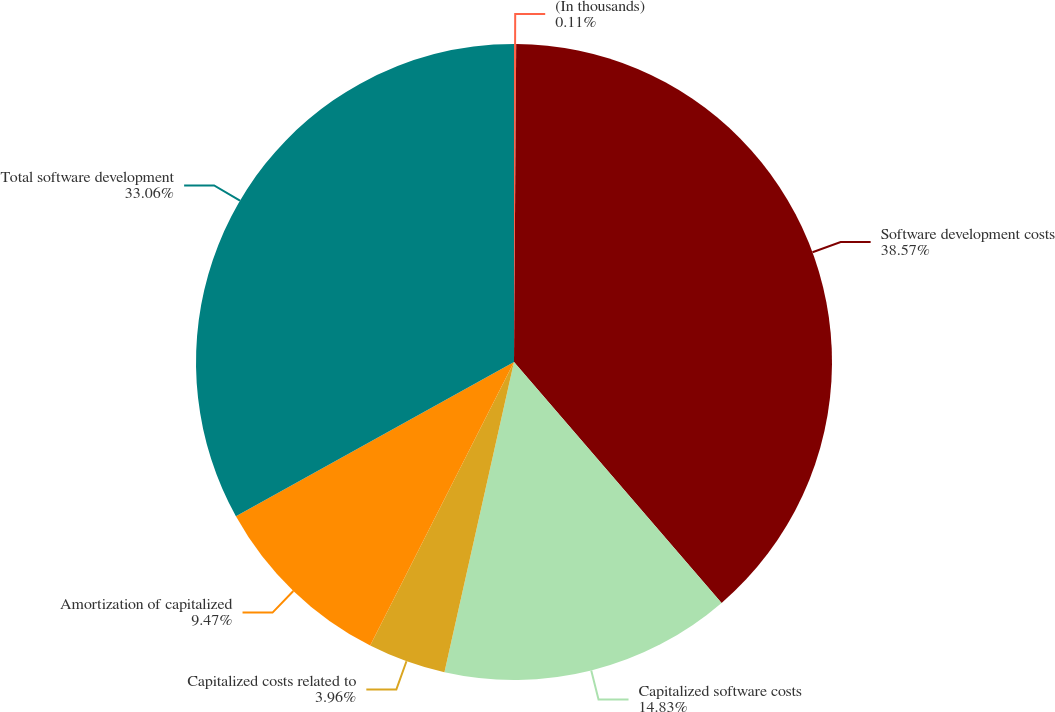<chart> <loc_0><loc_0><loc_500><loc_500><pie_chart><fcel>(In thousands)<fcel>Software development costs<fcel>Capitalized software costs<fcel>Capitalized costs related to<fcel>Amortization of capitalized<fcel>Total software development<nl><fcel>0.11%<fcel>38.57%<fcel>14.83%<fcel>3.96%<fcel>9.47%<fcel>33.06%<nl></chart> 